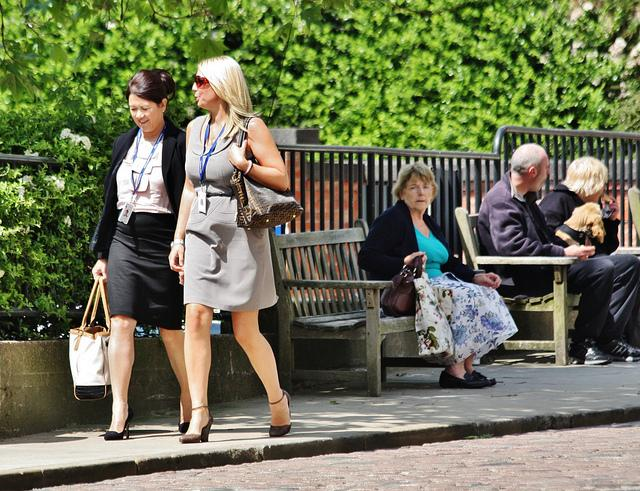Where are they likely to work from?

Choices:
A) office
B) home
C) warehouse
D) constraction office 